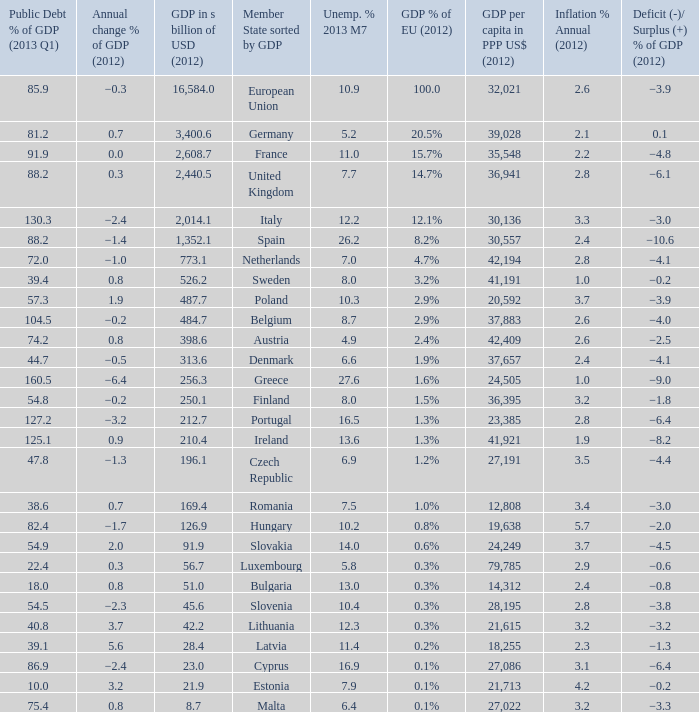4, and an inflation % yearly in 2012 of −0.6. 